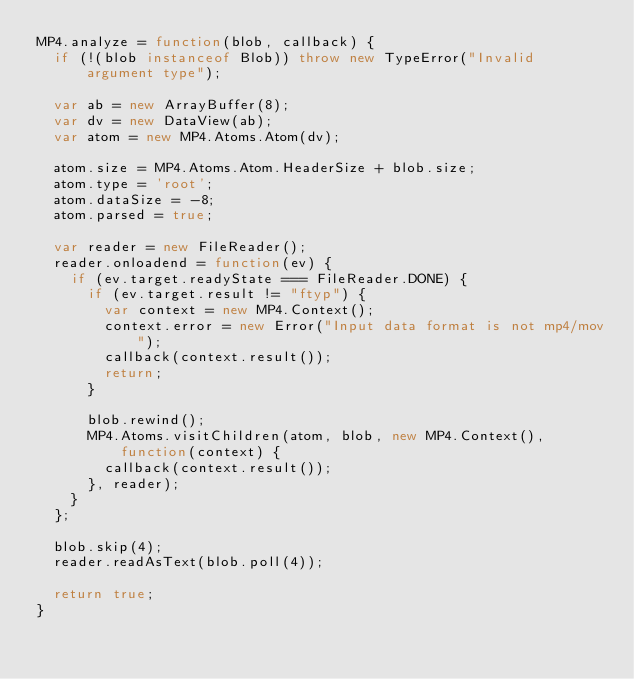Convert code to text. <code><loc_0><loc_0><loc_500><loc_500><_JavaScript_>MP4.analyze = function(blob, callback) {
  if (!(blob instanceof Blob)) throw new TypeError("Invalid argument type");

  var ab = new ArrayBuffer(8);
  var dv = new DataView(ab);
  var atom = new MP4.Atoms.Atom(dv);

  atom.size = MP4.Atoms.Atom.HeaderSize + blob.size;
  atom.type = 'root';
  atom.dataSize = -8;
  atom.parsed = true;

  var reader = new FileReader();
  reader.onloadend = function(ev) {
    if (ev.target.readyState === FileReader.DONE) {
      if (ev.target.result != "ftyp") {
        var context = new MP4.Context();
        context.error = new Error("Input data format is not mp4/mov");
        callback(context.result());
        return;
      }
  
      blob.rewind();
      MP4.Atoms.visitChildren(atom, blob, new MP4.Context(), function(context) {
        callback(context.result());
      }, reader);
    }
  };

  blob.skip(4);
  reader.readAsText(blob.poll(4));

  return true;
}
</code> 